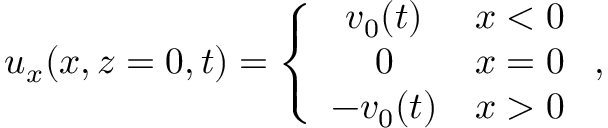Convert formula to latex. <formula><loc_0><loc_0><loc_500><loc_500>\begin{array} { r } { u _ { x } ( x , z = 0 , t ) = \left \{ \begin{array} { c c } { v _ { 0 } ( t ) } & { x < 0 } \\ { 0 } & { x = 0 } \\ { - v _ { 0 } ( t ) } & { x > 0 } \end{array} , } \end{array}</formula> 